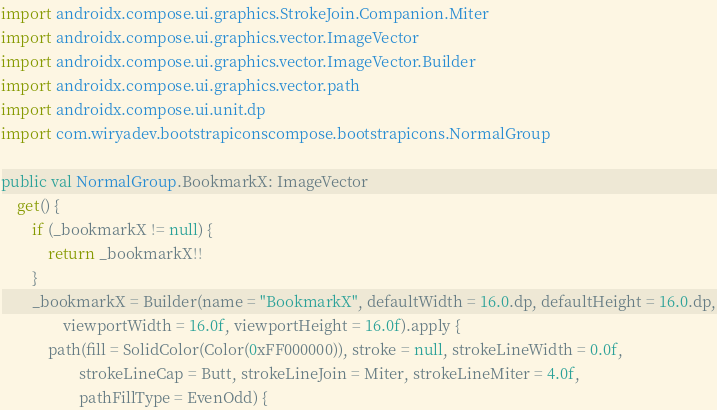<code> <loc_0><loc_0><loc_500><loc_500><_Kotlin_>import androidx.compose.ui.graphics.StrokeJoin.Companion.Miter
import androidx.compose.ui.graphics.vector.ImageVector
import androidx.compose.ui.graphics.vector.ImageVector.Builder
import androidx.compose.ui.graphics.vector.path
import androidx.compose.ui.unit.dp
import com.wiryadev.bootstrapiconscompose.bootstrapicons.NormalGroup

public val NormalGroup.BookmarkX: ImageVector
    get() {
        if (_bookmarkX != null) {
            return _bookmarkX!!
        }
        _bookmarkX = Builder(name = "BookmarkX", defaultWidth = 16.0.dp, defaultHeight = 16.0.dp,
                viewportWidth = 16.0f, viewportHeight = 16.0f).apply {
            path(fill = SolidColor(Color(0xFF000000)), stroke = null, strokeLineWidth = 0.0f,
                    strokeLineCap = Butt, strokeLineJoin = Miter, strokeLineMiter = 4.0f,
                    pathFillType = EvenOdd) {</code> 